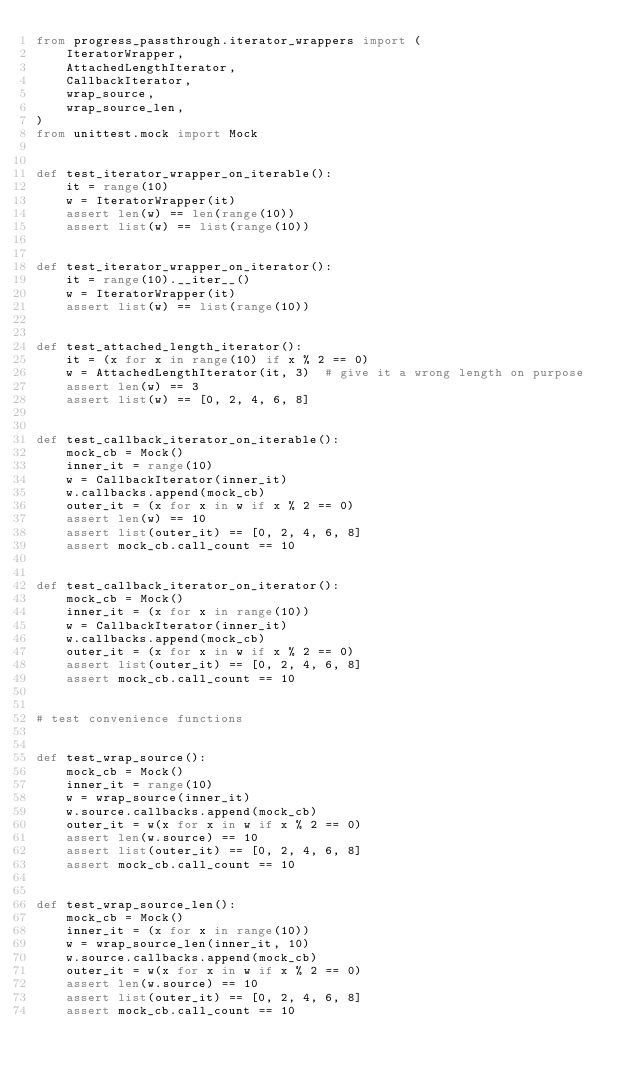Convert code to text. <code><loc_0><loc_0><loc_500><loc_500><_Python_>from progress_passthrough.iterator_wrappers import (
    IteratorWrapper,
    AttachedLengthIterator,
    CallbackIterator,
    wrap_source,
    wrap_source_len,
)
from unittest.mock import Mock


def test_iterator_wrapper_on_iterable():
    it = range(10)
    w = IteratorWrapper(it)
    assert len(w) == len(range(10))
    assert list(w) == list(range(10))


def test_iterator_wrapper_on_iterator():
    it = range(10).__iter__()
    w = IteratorWrapper(it)
    assert list(w) == list(range(10))


def test_attached_length_iterator():
    it = (x for x in range(10) if x % 2 == 0)
    w = AttachedLengthIterator(it, 3)  # give it a wrong length on purpose
    assert len(w) == 3
    assert list(w) == [0, 2, 4, 6, 8]


def test_callback_iterator_on_iterable():
    mock_cb = Mock()
    inner_it = range(10)
    w = CallbackIterator(inner_it)
    w.callbacks.append(mock_cb)
    outer_it = (x for x in w if x % 2 == 0)
    assert len(w) == 10
    assert list(outer_it) == [0, 2, 4, 6, 8]
    assert mock_cb.call_count == 10


def test_callback_iterator_on_iterator():
    mock_cb = Mock()
    inner_it = (x for x in range(10))
    w = CallbackIterator(inner_it)
    w.callbacks.append(mock_cb)
    outer_it = (x for x in w if x % 2 == 0)
    assert list(outer_it) == [0, 2, 4, 6, 8]
    assert mock_cb.call_count == 10


# test convenience functions


def test_wrap_source():
    mock_cb = Mock()
    inner_it = range(10)
    w = wrap_source(inner_it)
    w.source.callbacks.append(mock_cb)
    outer_it = w(x for x in w if x % 2 == 0)
    assert len(w.source) == 10
    assert list(outer_it) == [0, 2, 4, 6, 8]
    assert mock_cb.call_count == 10


def test_wrap_source_len():
    mock_cb = Mock()
    inner_it = (x for x in range(10))
    w = wrap_source_len(inner_it, 10)
    w.source.callbacks.append(mock_cb)
    outer_it = w(x for x in w if x % 2 == 0)
    assert len(w.source) == 10
    assert list(outer_it) == [0, 2, 4, 6, 8]
    assert mock_cb.call_count == 10
</code> 